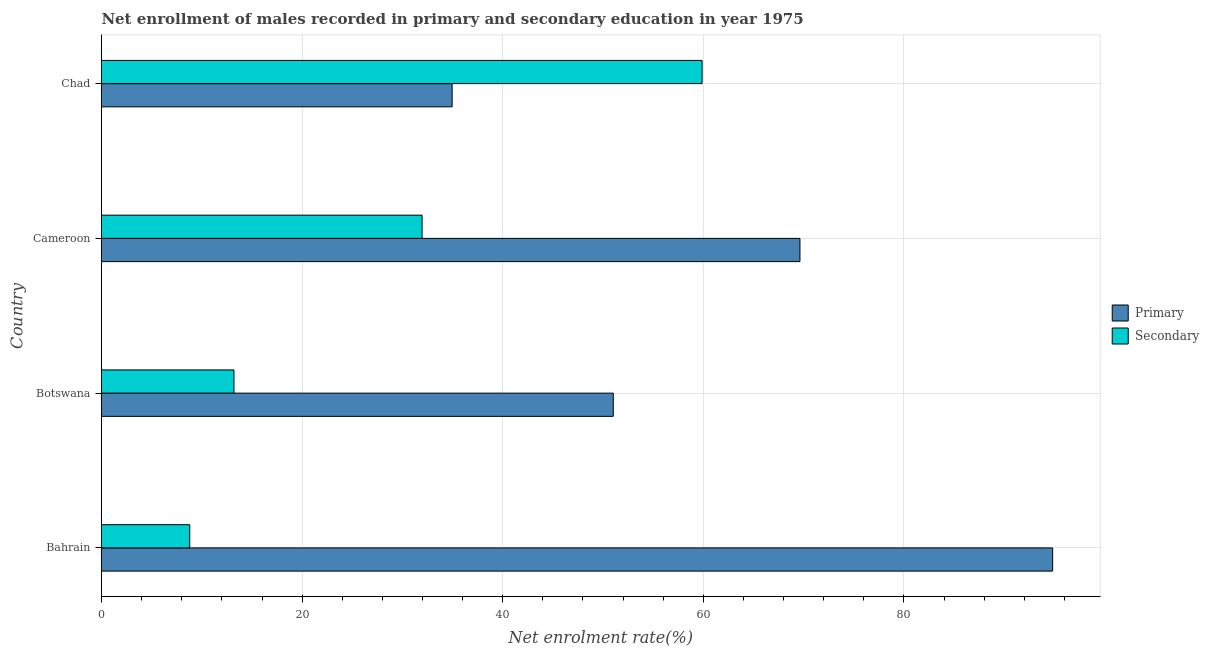How many different coloured bars are there?
Offer a terse response. 2. How many groups of bars are there?
Ensure brevity in your answer.  4. Are the number of bars per tick equal to the number of legend labels?
Your answer should be very brief. Yes. Are the number of bars on each tick of the Y-axis equal?
Ensure brevity in your answer.  Yes. How many bars are there on the 4th tick from the top?
Keep it short and to the point. 2. What is the label of the 2nd group of bars from the top?
Make the answer very short. Cameroon. What is the enrollment rate in secondary education in Cameroon?
Your answer should be very brief. 31.96. Across all countries, what is the maximum enrollment rate in secondary education?
Provide a short and direct response. 59.87. Across all countries, what is the minimum enrollment rate in primary education?
Offer a terse response. 34.95. In which country was the enrollment rate in primary education maximum?
Your answer should be very brief. Bahrain. In which country was the enrollment rate in primary education minimum?
Offer a terse response. Chad. What is the total enrollment rate in primary education in the graph?
Your answer should be compact. 250.42. What is the difference between the enrollment rate in secondary education in Cameroon and that in Chad?
Keep it short and to the point. -27.91. What is the difference between the enrollment rate in secondary education in Botswana and the enrollment rate in primary education in Chad?
Make the answer very short. -21.75. What is the average enrollment rate in primary education per country?
Offer a terse response. 62.61. What is the difference between the enrollment rate in secondary education and enrollment rate in primary education in Botswana?
Provide a short and direct response. -37.81. In how many countries, is the enrollment rate in primary education greater than 84 %?
Your response must be concise. 1. What is the ratio of the enrollment rate in primary education in Botswana to that in Cameroon?
Offer a very short reply. 0.73. Is the difference between the enrollment rate in primary education in Botswana and Cameroon greater than the difference between the enrollment rate in secondary education in Botswana and Cameroon?
Your answer should be very brief. Yes. What is the difference between the highest and the second highest enrollment rate in secondary education?
Your answer should be very brief. 27.91. What is the difference between the highest and the lowest enrollment rate in secondary education?
Your response must be concise. 51.08. In how many countries, is the enrollment rate in primary education greater than the average enrollment rate in primary education taken over all countries?
Provide a succinct answer. 2. What does the 2nd bar from the top in Cameroon represents?
Your answer should be very brief. Primary. What does the 1st bar from the bottom in Cameroon represents?
Provide a short and direct response. Primary. How many bars are there?
Provide a succinct answer. 8. How many countries are there in the graph?
Your response must be concise. 4. Are the values on the major ticks of X-axis written in scientific E-notation?
Your answer should be very brief. No. Does the graph contain any zero values?
Provide a short and direct response. No. Does the graph contain grids?
Your answer should be compact. Yes. How are the legend labels stacked?
Give a very brief answer. Vertical. What is the title of the graph?
Give a very brief answer. Net enrollment of males recorded in primary and secondary education in year 1975. What is the label or title of the X-axis?
Provide a succinct answer. Net enrolment rate(%). What is the label or title of the Y-axis?
Ensure brevity in your answer.  Country. What is the Net enrolment rate(%) in Primary in Bahrain?
Offer a very short reply. 94.82. What is the Net enrolment rate(%) in Secondary in Bahrain?
Offer a very short reply. 8.8. What is the Net enrolment rate(%) in Primary in Botswana?
Give a very brief answer. 51.02. What is the Net enrolment rate(%) in Secondary in Botswana?
Keep it short and to the point. 13.21. What is the Net enrolment rate(%) of Primary in Cameroon?
Give a very brief answer. 69.63. What is the Net enrolment rate(%) in Secondary in Cameroon?
Make the answer very short. 31.96. What is the Net enrolment rate(%) of Primary in Chad?
Make the answer very short. 34.95. What is the Net enrolment rate(%) in Secondary in Chad?
Ensure brevity in your answer.  59.87. Across all countries, what is the maximum Net enrolment rate(%) in Primary?
Ensure brevity in your answer.  94.82. Across all countries, what is the maximum Net enrolment rate(%) in Secondary?
Ensure brevity in your answer.  59.87. Across all countries, what is the minimum Net enrolment rate(%) in Primary?
Ensure brevity in your answer.  34.95. Across all countries, what is the minimum Net enrolment rate(%) in Secondary?
Keep it short and to the point. 8.8. What is the total Net enrolment rate(%) in Primary in the graph?
Keep it short and to the point. 250.42. What is the total Net enrolment rate(%) in Secondary in the graph?
Your response must be concise. 113.83. What is the difference between the Net enrolment rate(%) of Primary in Bahrain and that in Botswana?
Your response must be concise. 43.8. What is the difference between the Net enrolment rate(%) of Secondary in Bahrain and that in Botswana?
Make the answer very short. -4.41. What is the difference between the Net enrolment rate(%) in Primary in Bahrain and that in Cameroon?
Your answer should be very brief. 25.19. What is the difference between the Net enrolment rate(%) of Secondary in Bahrain and that in Cameroon?
Give a very brief answer. -23.16. What is the difference between the Net enrolment rate(%) in Primary in Bahrain and that in Chad?
Give a very brief answer. 59.87. What is the difference between the Net enrolment rate(%) of Secondary in Bahrain and that in Chad?
Keep it short and to the point. -51.08. What is the difference between the Net enrolment rate(%) in Primary in Botswana and that in Cameroon?
Provide a short and direct response. -18.61. What is the difference between the Net enrolment rate(%) in Secondary in Botswana and that in Cameroon?
Give a very brief answer. -18.75. What is the difference between the Net enrolment rate(%) of Primary in Botswana and that in Chad?
Make the answer very short. 16.07. What is the difference between the Net enrolment rate(%) in Secondary in Botswana and that in Chad?
Your response must be concise. -46.67. What is the difference between the Net enrolment rate(%) of Primary in Cameroon and that in Chad?
Provide a short and direct response. 34.68. What is the difference between the Net enrolment rate(%) of Secondary in Cameroon and that in Chad?
Your response must be concise. -27.91. What is the difference between the Net enrolment rate(%) of Primary in Bahrain and the Net enrolment rate(%) of Secondary in Botswana?
Ensure brevity in your answer.  81.62. What is the difference between the Net enrolment rate(%) of Primary in Bahrain and the Net enrolment rate(%) of Secondary in Cameroon?
Ensure brevity in your answer.  62.86. What is the difference between the Net enrolment rate(%) of Primary in Bahrain and the Net enrolment rate(%) of Secondary in Chad?
Ensure brevity in your answer.  34.95. What is the difference between the Net enrolment rate(%) of Primary in Botswana and the Net enrolment rate(%) of Secondary in Cameroon?
Provide a short and direct response. 19.06. What is the difference between the Net enrolment rate(%) in Primary in Botswana and the Net enrolment rate(%) in Secondary in Chad?
Your answer should be compact. -8.85. What is the difference between the Net enrolment rate(%) in Primary in Cameroon and the Net enrolment rate(%) in Secondary in Chad?
Keep it short and to the point. 9.76. What is the average Net enrolment rate(%) of Primary per country?
Your answer should be compact. 62.61. What is the average Net enrolment rate(%) of Secondary per country?
Keep it short and to the point. 28.46. What is the difference between the Net enrolment rate(%) of Primary and Net enrolment rate(%) of Secondary in Bahrain?
Offer a very short reply. 86.03. What is the difference between the Net enrolment rate(%) in Primary and Net enrolment rate(%) in Secondary in Botswana?
Keep it short and to the point. 37.81. What is the difference between the Net enrolment rate(%) of Primary and Net enrolment rate(%) of Secondary in Cameroon?
Provide a succinct answer. 37.67. What is the difference between the Net enrolment rate(%) of Primary and Net enrolment rate(%) of Secondary in Chad?
Ensure brevity in your answer.  -24.92. What is the ratio of the Net enrolment rate(%) in Primary in Bahrain to that in Botswana?
Give a very brief answer. 1.86. What is the ratio of the Net enrolment rate(%) of Secondary in Bahrain to that in Botswana?
Ensure brevity in your answer.  0.67. What is the ratio of the Net enrolment rate(%) of Primary in Bahrain to that in Cameroon?
Provide a short and direct response. 1.36. What is the ratio of the Net enrolment rate(%) of Secondary in Bahrain to that in Cameroon?
Ensure brevity in your answer.  0.28. What is the ratio of the Net enrolment rate(%) of Primary in Bahrain to that in Chad?
Provide a short and direct response. 2.71. What is the ratio of the Net enrolment rate(%) of Secondary in Bahrain to that in Chad?
Provide a succinct answer. 0.15. What is the ratio of the Net enrolment rate(%) of Primary in Botswana to that in Cameroon?
Provide a succinct answer. 0.73. What is the ratio of the Net enrolment rate(%) of Secondary in Botswana to that in Cameroon?
Your response must be concise. 0.41. What is the ratio of the Net enrolment rate(%) of Primary in Botswana to that in Chad?
Provide a short and direct response. 1.46. What is the ratio of the Net enrolment rate(%) in Secondary in Botswana to that in Chad?
Provide a short and direct response. 0.22. What is the ratio of the Net enrolment rate(%) in Primary in Cameroon to that in Chad?
Keep it short and to the point. 1.99. What is the ratio of the Net enrolment rate(%) in Secondary in Cameroon to that in Chad?
Your answer should be very brief. 0.53. What is the difference between the highest and the second highest Net enrolment rate(%) of Primary?
Offer a very short reply. 25.19. What is the difference between the highest and the second highest Net enrolment rate(%) of Secondary?
Your response must be concise. 27.91. What is the difference between the highest and the lowest Net enrolment rate(%) of Primary?
Give a very brief answer. 59.87. What is the difference between the highest and the lowest Net enrolment rate(%) of Secondary?
Your response must be concise. 51.08. 